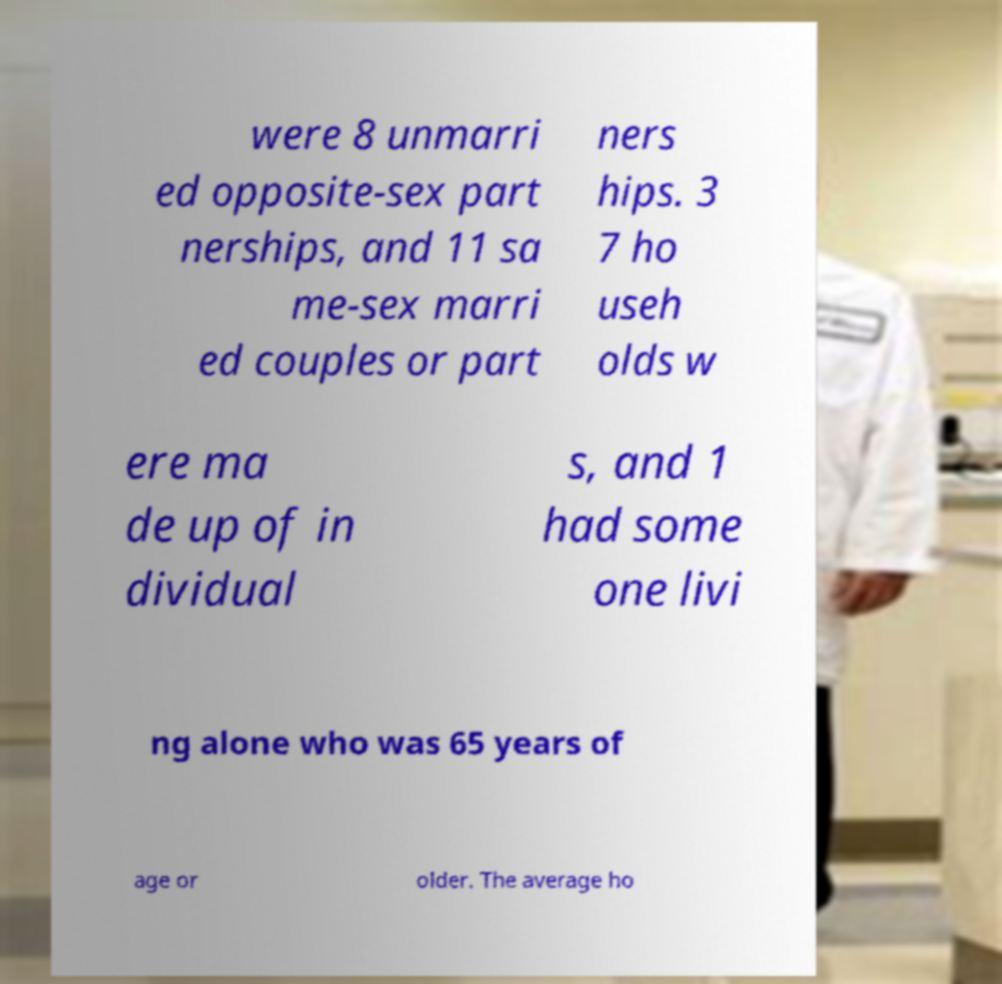Could you assist in decoding the text presented in this image and type it out clearly? were 8 unmarri ed opposite-sex part nerships, and 11 sa me-sex marri ed couples or part ners hips. 3 7 ho useh olds w ere ma de up of in dividual s, and 1 had some one livi ng alone who was 65 years of age or older. The average ho 